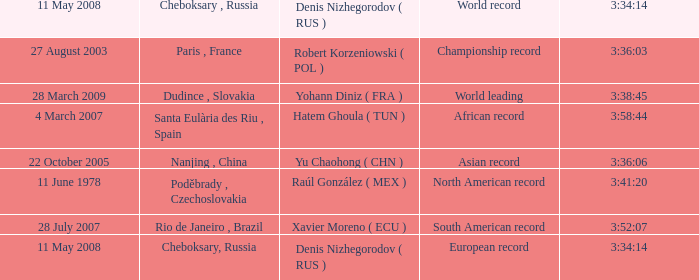When 3:41:20 is  3:34:14 what is cheboksary , russia? Poděbrady , Czechoslovakia. 